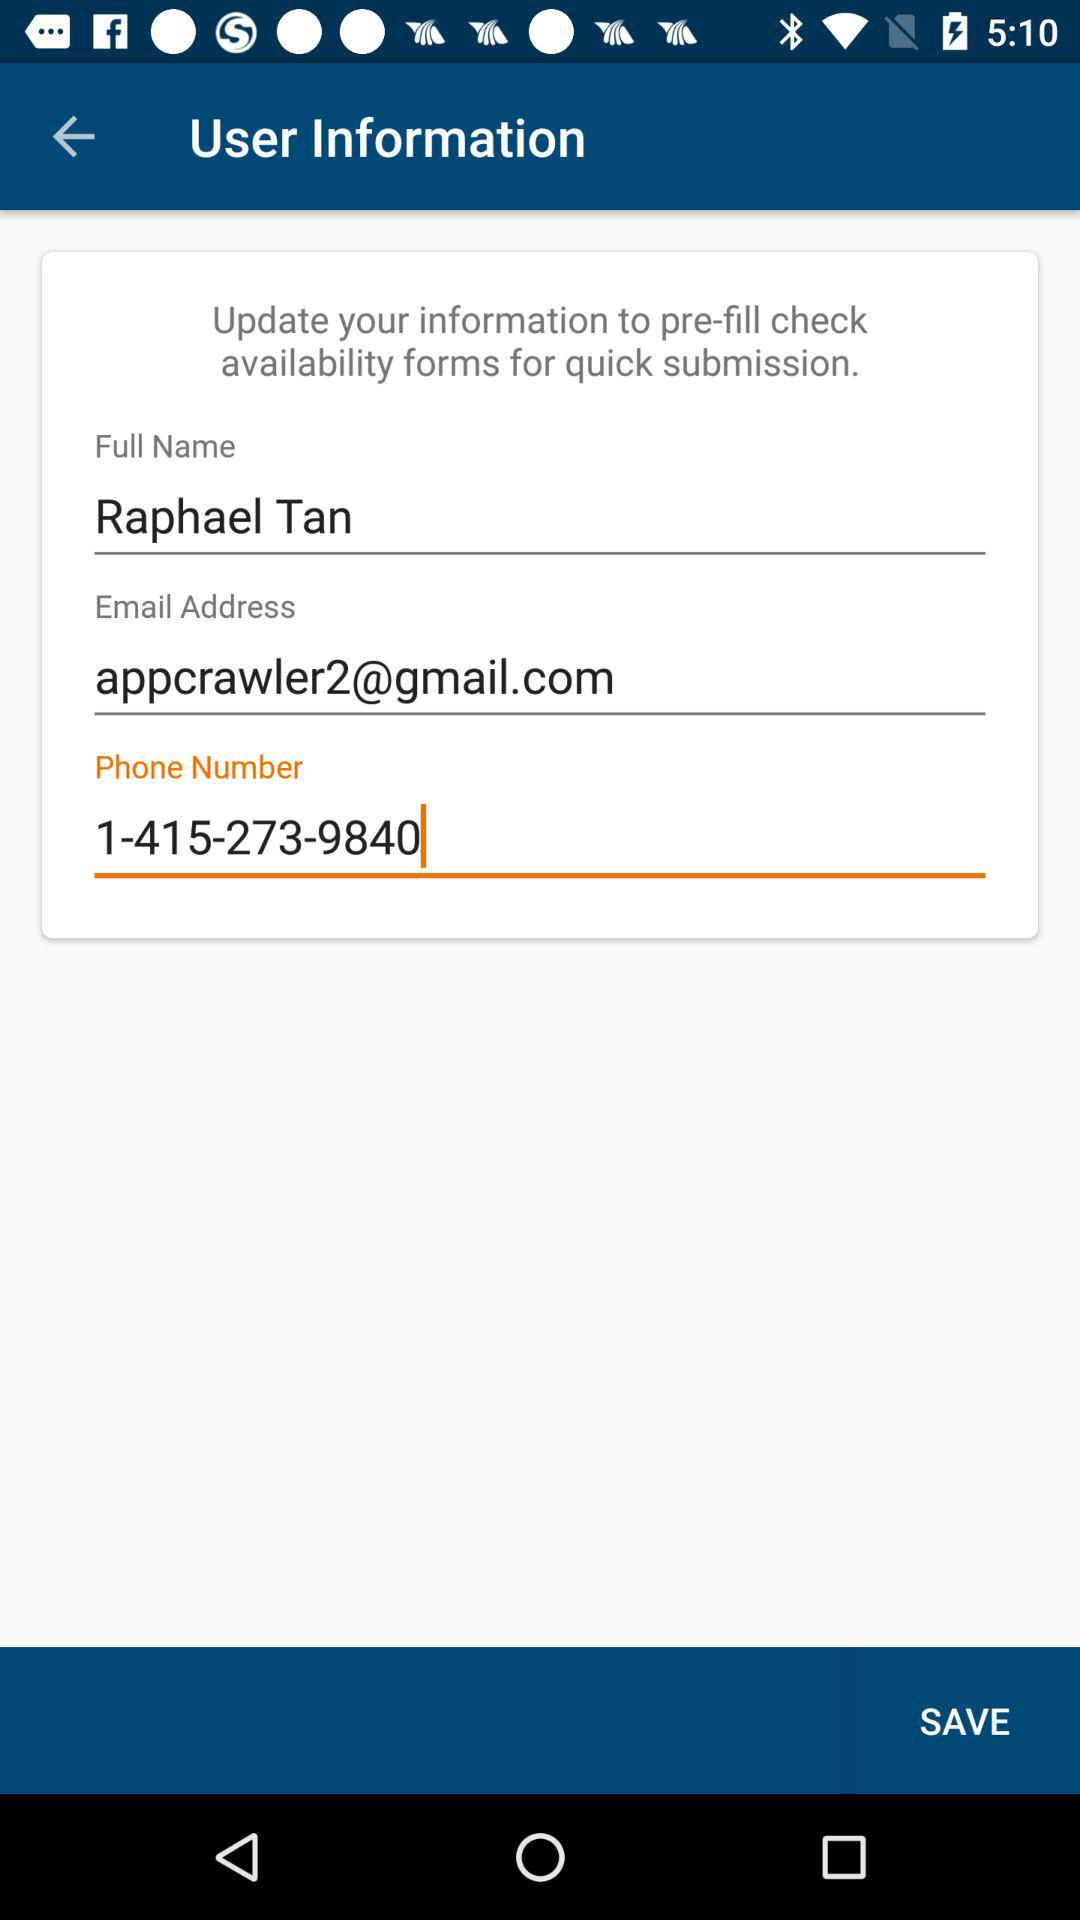What is the name of the person? The name of the person is Raphael Tan. 